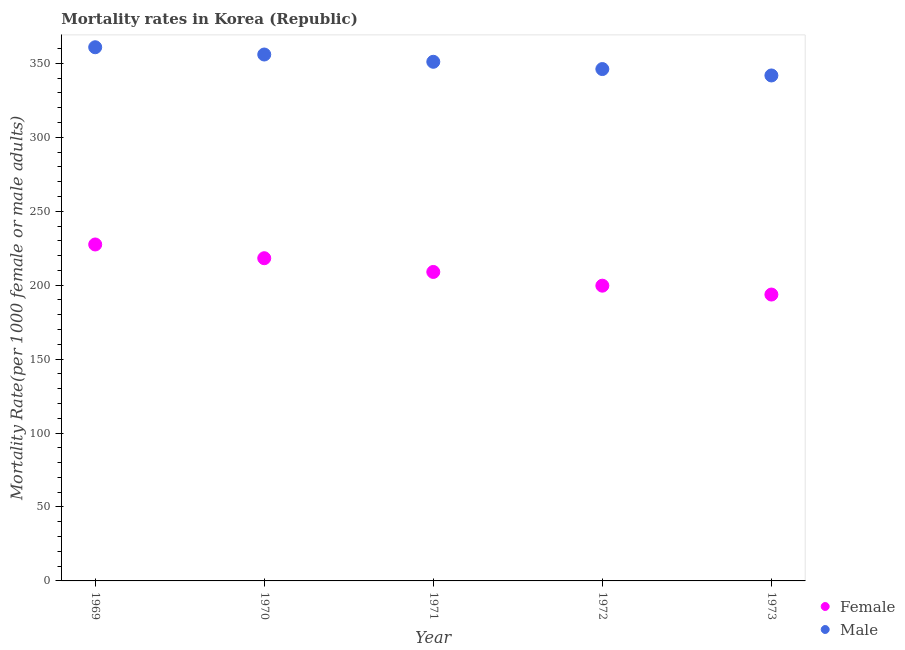What is the female mortality rate in 1973?
Your answer should be very brief. 193.69. Across all years, what is the maximum female mortality rate?
Ensure brevity in your answer.  227.55. Across all years, what is the minimum female mortality rate?
Give a very brief answer. 193.69. In which year was the female mortality rate maximum?
Keep it short and to the point. 1969. In which year was the female mortality rate minimum?
Offer a terse response. 1973. What is the total male mortality rate in the graph?
Give a very brief answer. 1756.13. What is the difference between the female mortality rate in 1971 and that in 1972?
Your response must be concise. 9.29. What is the difference between the male mortality rate in 1973 and the female mortality rate in 1970?
Your answer should be very brief. 123.6. What is the average male mortality rate per year?
Make the answer very short. 351.23. In the year 1972, what is the difference between the male mortality rate and female mortality rate?
Your answer should be compact. 146.51. What is the ratio of the female mortality rate in 1971 to that in 1972?
Ensure brevity in your answer.  1.05. Is the difference between the female mortality rate in 1971 and 1973 greater than the difference between the male mortality rate in 1971 and 1973?
Ensure brevity in your answer.  Yes. What is the difference between the highest and the second highest female mortality rate?
Offer a very short reply. 9.29. What is the difference between the highest and the lowest female mortality rate?
Give a very brief answer. 33.86. How many years are there in the graph?
Keep it short and to the point. 5. What is the difference between two consecutive major ticks on the Y-axis?
Your answer should be compact. 50. Are the values on the major ticks of Y-axis written in scientific E-notation?
Ensure brevity in your answer.  No. Where does the legend appear in the graph?
Offer a terse response. Bottom right. How many legend labels are there?
Provide a short and direct response. 2. What is the title of the graph?
Ensure brevity in your answer.  Mortality rates in Korea (Republic). Does "Depositors" appear as one of the legend labels in the graph?
Your answer should be compact. No. What is the label or title of the Y-axis?
Provide a short and direct response. Mortality Rate(per 1000 female or male adults). What is the Mortality Rate(per 1000 female or male adults) of Female in 1969?
Your answer should be compact. 227.55. What is the Mortality Rate(per 1000 female or male adults) in Male in 1969?
Provide a succinct answer. 360.95. What is the Mortality Rate(per 1000 female or male adults) in Female in 1970?
Offer a very short reply. 218.26. What is the Mortality Rate(per 1000 female or male adults) of Male in 1970?
Provide a succinct answer. 356.03. What is the Mortality Rate(per 1000 female or male adults) of Female in 1971?
Your answer should be compact. 208.97. What is the Mortality Rate(per 1000 female or male adults) in Male in 1971?
Provide a succinct answer. 351.11. What is the Mortality Rate(per 1000 female or male adults) of Female in 1972?
Provide a succinct answer. 199.68. What is the Mortality Rate(per 1000 female or male adults) of Male in 1972?
Make the answer very short. 346.19. What is the Mortality Rate(per 1000 female or male adults) of Female in 1973?
Ensure brevity in your answer.  193.69. What is the Mortality Rate(per 1000 female or male adults) in Male in 1973?
Your answer should be compact. 341.86. Across all years, what is the maximum Mortality Rate(per 1000 female or male adults) of Female?
Make the answer very short. 227.55. Across all years, what is the maximum Mortality Rate(per 1000 female or male adults) in Male?
Offer a very short reply. 360.95. Across all years, what is the minimum Mortality Rate(per 1000 female or male adults) in Female?
Your answer should be compact. 193.69. Across all years, what is the minimum Mortality Rate(per 1000 female or male adults) in Male?
Provide a short and direct response. 341.86. What is the total Mortality Rate(per 1000 female or male adults) in Female in the graph?
Make the answer very short. 1048.14. What is the total Mortality Rate(per 1000 female or male adults) in Male in the graph?
Offer a terse response. 1756.13. What is the difference between the Mortality Rate(per 1000 female or male adults) in Female in 1969 and that in 1970?
Provide a short and direct response. 9.29. What is the difference between the Mortality Rate(per 1000 female or male adults) of Male in 1969 and that in 1970?
Provide a succinct answer. 4.92. What is the difference between the Mortality Rate(per 1000 female or male adults) in Female in 1969 and that in 1971?
Your answer should be compact. 18.57. What is the difference between the Mortality Rate(per 1000 female or male adults) of Male in 1969 and that in 1971?
Your answer should be very brief. 9.84. What is the difference between the Mortality Rate(per 1000 female or male adults) of Female in 1969 and that in 1972?
Keep it short and to the point. 27.86. What is the difference between the Mortality Rate(per 1000 female or male adults) of Male in 1969 and that in 1972?
Offer a terse response. 14.76. What is the difference between the Mortality Rate(per 1000 female or male adults) of Female in 1969 and that in 1973?
Give a very brief answer. 33.86. What is the difference between the Mortality Rate(per 1000 female or male adults) in Male in 1969 and that in 1973?
Your answer should be compact. 19.09. What is the difference between the Mortality Rate(per 1000 female or male adults) of Female in 1970 and that in 1971?
Make the answer very short. 9.29. What is the difference between the Mortality Rate(per 1000 female or male adults) in Male in 1970 and that in 1971?
Provide a short and direct response. 4.92. What is the difference between the Mortality Rate(per 1000 female or male adults) of Female in 1970 and that in 1972?
Keep it short and to the point. 18.57. What is the difference between the Mortality Rate(per 1000 female or male adults) in Male in 1970 and that in 1972?
Provide a succinct answer. 9.84. What is the difference between the Mortality Rate(per 1000 female or male adults) of Female in 1970 and that in 1973?
Offer a terse response. 24.57. What is the difference between the Mortality Rate(per 1000 female or male adults) in Male in 1970 and that in 1973?
Offer a very short reply. 14.17. What is the difference between the Mortality Rate(per 1000 female or male adults) of Female in 1971 and that in 1972?
Offer a very short reply. 9.29. What is the difference between the Mortality Rate(per 1000 female or male adults) in Male in 1971 and that in 1972?
Your response must be concise. 4.92. What is the difference between the Mortality Rate(per 1000 female or male adults) of Female in 1971 and that in 1973?
Provide a succinct answer. 15.28. What is the difference between the Mortality Rate(per 1000 female or male adults) in Male in 1971 and that in 1973?
Ensure brevity in your answer.  9.25. What is the difference between the Mortality Rate(per 1000 female or male adults) in Female in 1972 and that in 1973?
Offer a terse response. 6. What is the difference between the Mortality Rate(per 1000 female or male adults) of Male in 1972 and that in 1973?
Keep it short and to the point. 4.33. What is the difference between the Mortality Rate(per 1000 female or male adults) of Female in 1969 and the Mortality Rate(per 1000 female or male adults) of Male in 1970?
Your response must be concise. -128.48. What is the difference between the Mortality Rate(per 1000 female or male adults) of Female in 1969 and the Mortality Rate(per 1000 female or male adults) of Male in 1971?
Offer a terse response. -123.56. What is the difference between the Mortality Rate(per 1000 female or male adults) in Female in 1969 and the Mortality Rate(per 1000 female or male adults) in Male in 1972?
Offer a terse response. -118.64. What is the difference between the Mortality Rate(per 1000 female or male adults) of Female in 1969 and the Mortality Rate(per 1000 female or male adults) of Male in 1973?
Your answer should be very brief. -114.31. What is the difference between the Mortality Rate(per 1000 female or male adults) in Female in 1970 and the Mortality Rate(per 1000 female or male adults) in Male in 1971?
Your response must be concise. -132.85. What is the difference between the Mortality Rate(per 1000 female or male adults) of Female in 1970 and the Mortality Rate(per 1000 female or male adults) of Male in 1972?
Give a very brief answer. -127.93. What is the difference between the Mortality Rate(per 1000 female or male adults) in Female in 1970 and the Mortality Rate(per 1000 female or male adults) in Male in 1973?
Provide a succinct answer. -123.6. What is the difference between the Mortality Rate(per 1000 female or male adults) of Female in 1971 and the Mortality Rate(per 1000 female or male adults) of Male in 1972?
Give a very brief answer. -137.22. What is the difference between the Mortality Rate(per 1000 female or male adults) of Female in 1971 and the Mortality Rate(per 1000 female or male adults) of Male in 1973?
Ensure brevity in your answer.  -132.89. What is the difference between the Mortality Rate(per 1000 female or male adults) of Female in 1972 and the Mortality Rate(per 1000 female or male adults) of Male in 1973?
Make the answer very short. -142.18. What is the average Mortality Rate(per 1000 female or male adults) of Female per year?
Ensure brevity in your answer.  209.63. What is the average Mortality Rate(per 1000 female or male adults) in Male per year?
Your response must be concise. 351.23. In the year 1969, what is the difference between the Mortality Rate(per 1000 female or male adults) in Female and Mortality Rate(per 1000 female or male adults) in Male?
Keep it short and to the point. -133.4. In the year 1970, what is the difference between the Mortality Rate(per 1000 female or male adults) in Female and Mortality Rate(per 1000 female or male adults) in Male?
Provide a succinct answer. -137.77. In the year 1971, what is the difference between the Mortality Rate(per 1000 female or male adults) of Female and Mortality Rate(per 1000 female or male adults) of Male?
Keep it short and to the point. -142.14. In the year 1972, what is the difference between the Mortality Rate(per 1000 female or male adults) of Female and Mortality Rate(per 1000 female or male adults) of Male?
Your answer should be compact. -146.51. In the year 1973, what is the difference between the Mortality Rate(per 1000 female or male adults) of Female and Mortality Rate(per 1000 female or male adults) of Male?
Ensure brevity in your answer.  -148.17. What is the ratio of the Mortality Rate(per 1000 female or male adults) of Female in 1969 to that in 1970?
Give a very brief answer. 1.04. What is the ratio of the Mortality Rate(per 1000 female or male adults) of Male in 1969 to that in 1970?
Offer a very short reply. 1.01. What is the ratio of the Mortality Rate(per 1000 female or male adults) in Female in 1969 to that in 1971?
Offer a very short reply. 1.09. What is the ratio of the Mortality Rate(per 1000 female or male adults) of Male in 1969 to that in 1971?
Offer a very short reply. 1.03. What is the ratio of the Mortality Rate(per 1000 female or male adults) in Female in 1969 to that in 1972?
Provide a short and direct response. 1.14. What is the ratio of the Mortality Rate(per 1000 female or male adults) of Male in 1969 to that in 1972?
Provide a short and direct response. 1.04. What is the ratio of the Mortality Rate(per 1000 female or male adults) of Female in 1969 to that in 1973?
Provide a short and direct response. 1.17. What is the ratio of the Mortality Rate(per 1000 female or male adults) of Male in 1969 to that in 1973?
Ensure brevity in your answer.  1.06. What is the ratio of the Mortality Rate(per 1000 female or male adults) in Female in 1970 to that in 1971?
Offer a very short reply. 1.04. What is the ratio of the Mortality Rate(per 1000 female or male adults) of Male in 1970 to that in 1971?
Provide a succinct answer. 1.01. What is the ratio of the Mortality Rate(per 1000 female or male adults) of Female in 1970 to that in 1972?
Keep it short and to the point. 1.09. What is the ratio of the Mortality Rate(per 1000 female or male adults) in Male in 1970 to that in 1972?
Keep it short and to the point. 1.03. What is the ratio of the Mortality Rate(per 1000 female or male adults) in Female in 1970 to that in 1973?
Your answer should be very brief. 1.13. What is the ratio of the Mortality Rate(per 1000 female or male adults) in Male in 1970 to that in 1973?
Offer a very short reply. 1.04. What is the ratio of the Mortality Rate(per 1000 female or male adults) in Female in 1971 to that in 1972?
Your response must be concise. 1.05. What is the ratio of the Mortality Rate(per 1000 female or male adults) in Male in 1971 to that in 1972?
Your answer should be compact. 1.01. What is the ratio of the Mortality Rate(per 1000 female or male adults) in Female in 1971 to that in 1973?
Give a very brief answer. 1.08. What is the ratio of the Mortality Rate(per 1000 female or male adults) in Male in 1971 to that in 1973?
Provide a succinct answer. 1.03. What is the ratio of the Mortality Rate(per 1000 female or male adults) of Female in 1972 to that in 1973?
Your response must be concise. 1.03. What is the ratio of the Mortality Rate(per 1000 female or male adults) of Male in 1972 to that in 1973?
Provide a succinct answer. 1.01. What is the difference between the highest and the second highest Mortality Rate(per 1000 female or male adults) in Female?
Ensure brevity in your answer.  9.29. What is the difference between the highest and the second highest Mortality Rate(per 1000 female or male adults) in Male?
Ensure brevity in your answer.  4.92. What is the difference between the highest and the lowest Mortality Rate(per 1000 female or male adults) of Female?
Provide a succinct answer. 33.86. What is the difference between the highest and the lowest Mortality Rate(per 1000 female or male adults) in Male?
Provide a short and direct response. 19.09. 